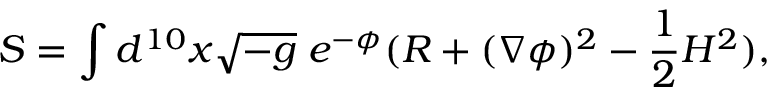Convert formula to latex. <formula><loc_0><loc_0><loc_500><loc_500>S = \int d ^ { 1 0 } x \sqrt { - g } \, e ^ { - \phi } ( R + ( \nabla \phi ) ^ { 2 } - \frac { 1 } { 2 } H ^ { 2 } ) ,</formula> 